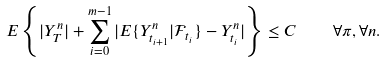<formula> <loc_0><loc_0><loc_500><loc_500>E \left \{ | Y ^ { n } _ { T } | + \sum _ { i = 0 } ^ { m - 1 } | E \{ Y ^ { n } _ { t _ { i + 1 } } | \mathcal { F } _ { t _ { i } } \} - Y ^ { n } _ { t _ { i } } | \right \} \leq C \quad \forall \pi , \forall n .</formula> 